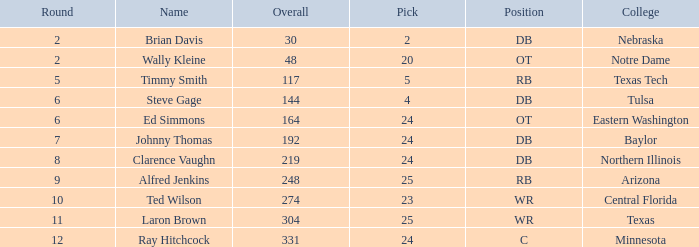What top round has a pick smaller than 2? None. 